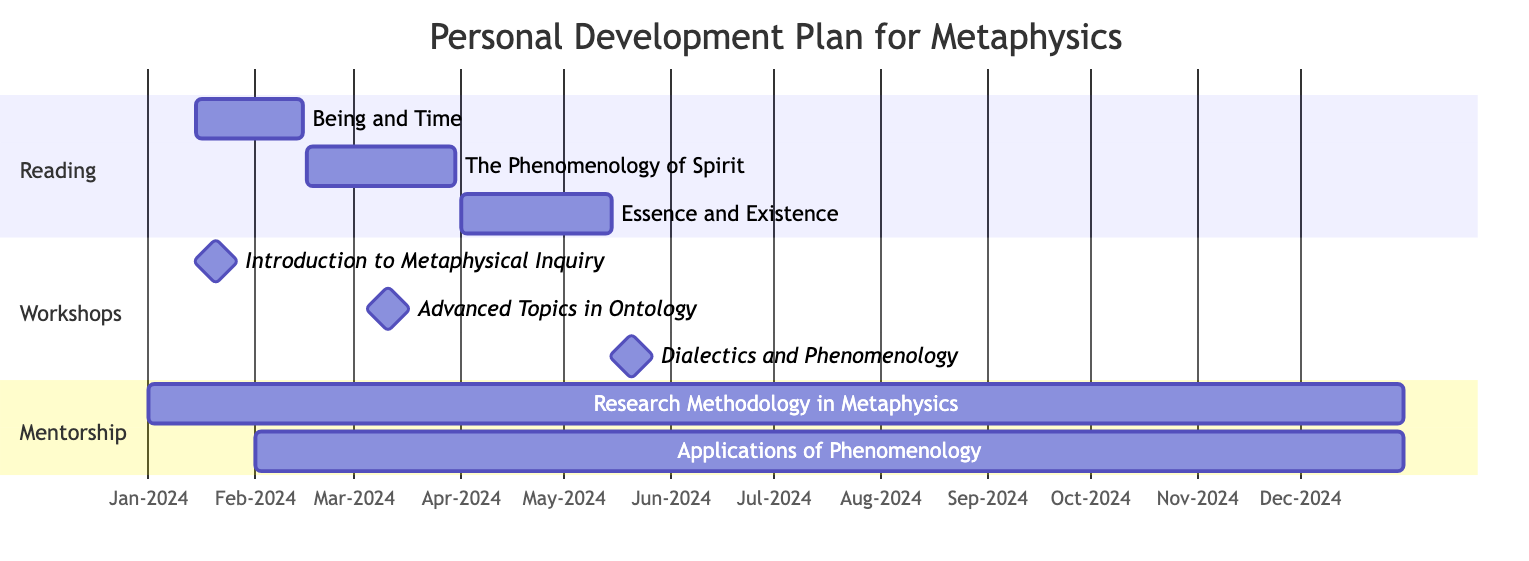What is the start date for "Being and Time"? The diagram shows the reading section with "Being and Time" listed along with its start and end dates. The start date provided is January 15, 2024.
Answer: January 15, 2024 How many workshops are planned in the personal development plan? In the workshops section of the diagram, there are three milestones listed, indicating a total of three workshops planned throughout the year.
Answer: 3 What is the end date for "Essence and Existence"? The diagram indicates the end date for "Essence and Existence" in the reading section, which is May 15, 2024.
Answer: May 15, 2024 What is the frequency of meetings with Dr. John Smith? In the mentorship section, the meeting frequency with Dr. John Smith is specified as "Monthly," indicating that these meetings will happen each month throughout the academic year.
Answer: Monthly During which month does the workshop "Advanced Topics in Ontology" occur? The diagram specifies that the workshop "Advanced Topics in Ontology" is scheduled for March 10, 2024, therefore it occurs in the month of March.
Answer: March Which reading title will be focused on last in this plan? By examining the reading section, "Essence and Existence" is the final title listed, which indicates it will be the last focus area in the reading plan.
Answer: Essence and Existence How many total mentorship meetings are anticipated with Dr. Emily Johnson? Since Dr. Emily Johnson's meetings occur bi-monthly from February to December, we calculate the number of months between those dates, resulting in a total of six anticipated meetings.
Answer: 6 What workshop is the first to take place in this plan? In the workshops section of the diagram, "Introduction to Metaphysical Inquiry" is listed first and is scheduled for January 20, 2024, making it the first workshop.
Answer: Introduction to Metaphysical Inquiry 